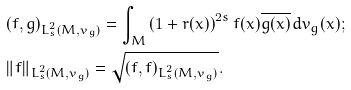Convert formula to latex. <formula><loc_0><loc_0><loc_500><loc_500>& ( f , g ) _ { L ^ { 2 } _ { s } ( M , v _ { g } ) } = \int _ { M } \left ( 1 + r ( x ) \right ) ^ { 2 s } f ( x ) \overline { g ( x ) } \, d v _ { g } ( x ) ; \\ & \| f \| _ { L ^ { 2 } _ { s } ( M , v _ { g } ) } = \sqrt { ( f , f ) _ { L ^ { 2 } _ { s } ( M , v _ { g } ) } } .</formula> 